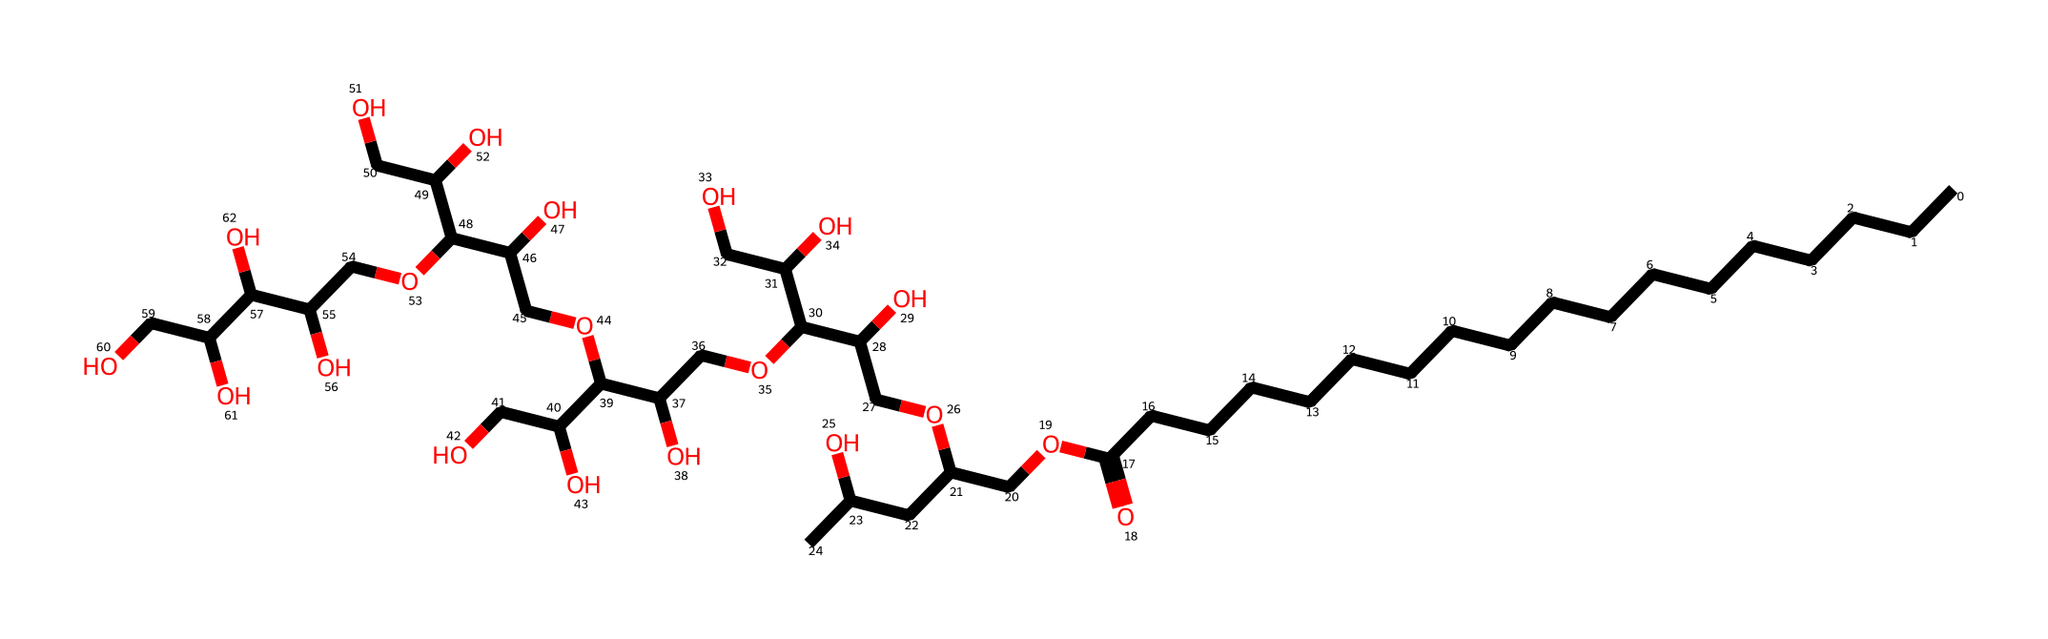how many carbon atoms are in polysorbate 80? By analyzing the SMILES representation, I can count the 'C' characters. The linear carbon chain and the branched groups indicate a total of 20 carbon atoms.
Answer: 20 what functional groups are present in polysorbate 80? In the SMILES, I can identify the presence of carboxylic acid (-COOH) and several hydroxyl (-OH) groups stemming from the alcohol components.
Answer: carboxylic acid, hydroxyl what is the total number of hydroxyl groups in polysorbate 80? By examining the SMILES, I can find the occurrences of 'O' that are part of alcohol functionalities. There are 10 hydroxyl groups in total observed in the structure.
Answer: 10 what type of surfactant is polysorbate 80? Being a nonionic surfactant, polysorbate 80 has a hydrophilic head (caused by polar hydroxyl groups) and a hydrophobic tail (the long alkyl chain), classifying it specifically as a nonionic surfactant.
Answer: nonionic how does the structure of polysorbate 80 affect its emulsifying properties? The structure shows a long hydrophobic carbon chain and multiple hydrophilic hydroxyl groups, which allows it to effectively stabilize emulsions by reducing surface tension between water and oil phases.
Answer: stabilizes emulsions how many ester linkages are present in polysorbate 80? By analyzing the structure, I can observe that there are four ester linkages formed between the fatty acid and the polyol portions of the molecule, counted by the positions of carbonyl and oxygen.
Answer: 4 what role does the hydrophobic tail play in polysorbate 80's function as a surfactant? The hydrophobic tail helps to solubilize nonpolar substances such as oils in water. The long chain creates a favorable interaction with oils, allowing for micelle formation and better emulsification.
Answer: solubilizes oils 